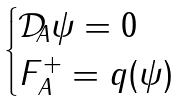Convert formula to latex. <formula><loc_0><loc_0><loc_500><loc_500>\begin{cases} \mathcal { D } _ { A } \psi = 0 \\ F ^ { + } _ { A } = q ( \psi ) \end{cases}</formula> 